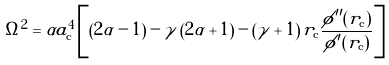<formula> <loc_0><loc_0><loc_500><loc_500>\Omega ^ { 2 } = \alpha a _ { \mathrm c } ^ { 4 } \left [ \left ( 2 \alpha - 1 \right ) - \gamma \left ( 2 \alpha + 1 \right ) - \left ( \gamma + 1 \right ) r _ { \mathrm c } \frac { \phi ^ { \prime \prime } ( r _ { \mathrm c } ) } { \phi ^ { \prime } ( r _ { \mathrm c } ) } \right ]</formula> 